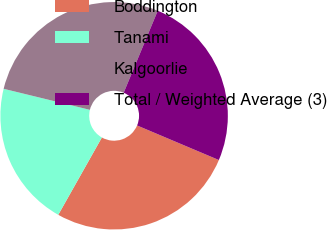<chart> <loc_0><loc_0><loc_500><loc_500><pie_chart><fcel>Boddington<fcel>Tanami<fcel>Kalgoorlie<fcel>Total / Weighted Average (3)<nl><fcel>26.81%<fcel>20.64%<fcel>27.46%<fcel>25.1%<nl></chart> 